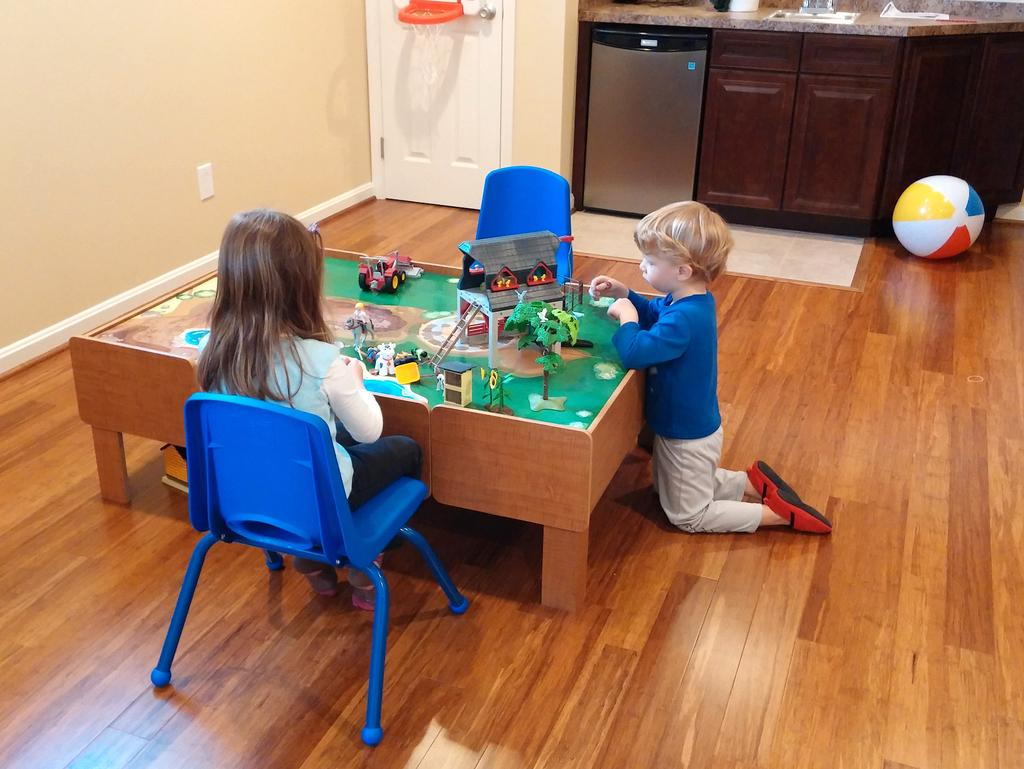What are the kids doing in the image? The kids are playing in the image. What are the kids playing with? The kids are playing with toys. What can be seen in the background of the image? There is a door and a shelf in the background of the image. What type of twig is being used as a toy by the kids in the image? There is no twig present in the image; the kids are playing with toys. What impulse might have led the kids to start playing with the toys in the image? The image does not provide information about the kids' motivations or impulses for playing with the toys. 